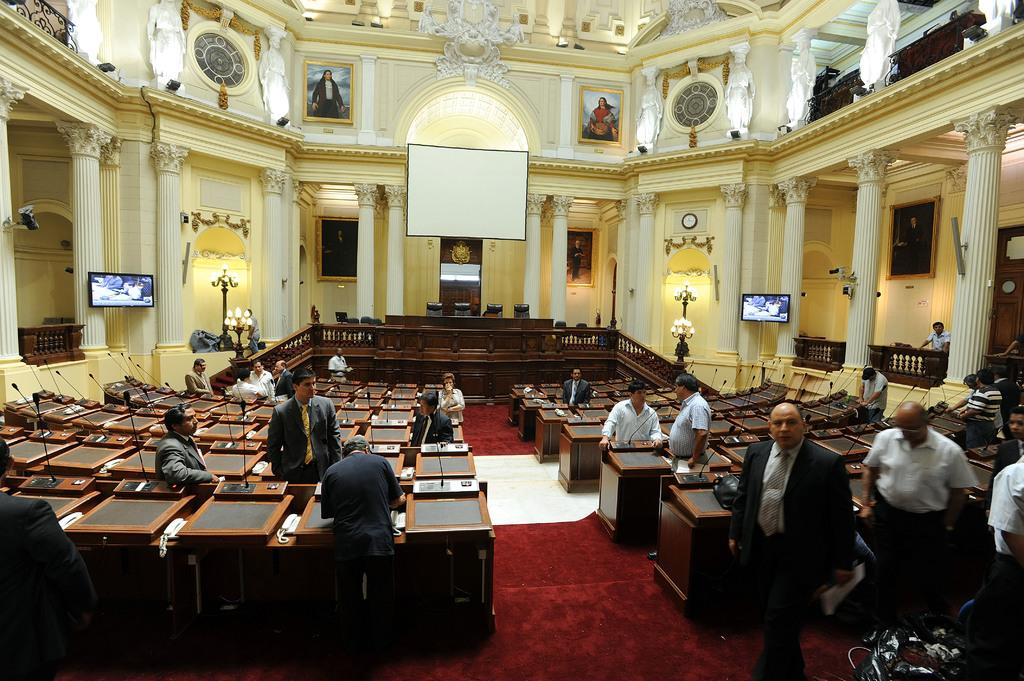What type of location is depicted in the image? The image shows an inside view of a building. What can be seen on the stage or platform in the image? There are podiums in the image. What can be used to illuminate the area in the image? Lights are visible in the image. What device is used for displaying visuals in the image? A projector is present in the image. Who is present in the image? There are people in the image. What is placed on the floor in the image? A floor mat is visible in the image. What other objects can be seen in the image? There are other objects in the image. What type of mark can be seen on the heart of the person in the image? There is no person or heart visible in the image; it shows an inside view of a building with various objects and people. 